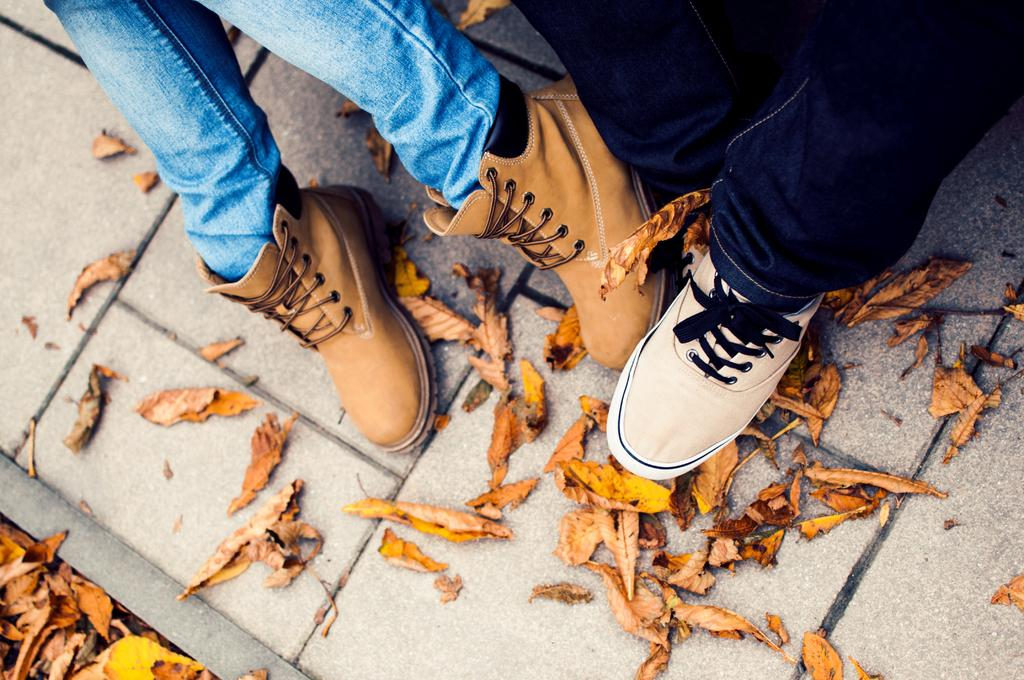What can be seen at the bottom of the image? There are legs of persons with shoes in the image. What type of flooring is visible in the image? The ground has a brick floor. What else is present on the ground in the image? There are dried leaves on the ground in the image. What type of battle is taking place in the image? There is: There is no battle present in the image; it only shows legs of persons with shoes, a brick floor, and dried leaves on the ground. Can you tell me the name of the father in the image? There is no father or any person's name mentioned in the image; it only shows legs of persons with shoes. 